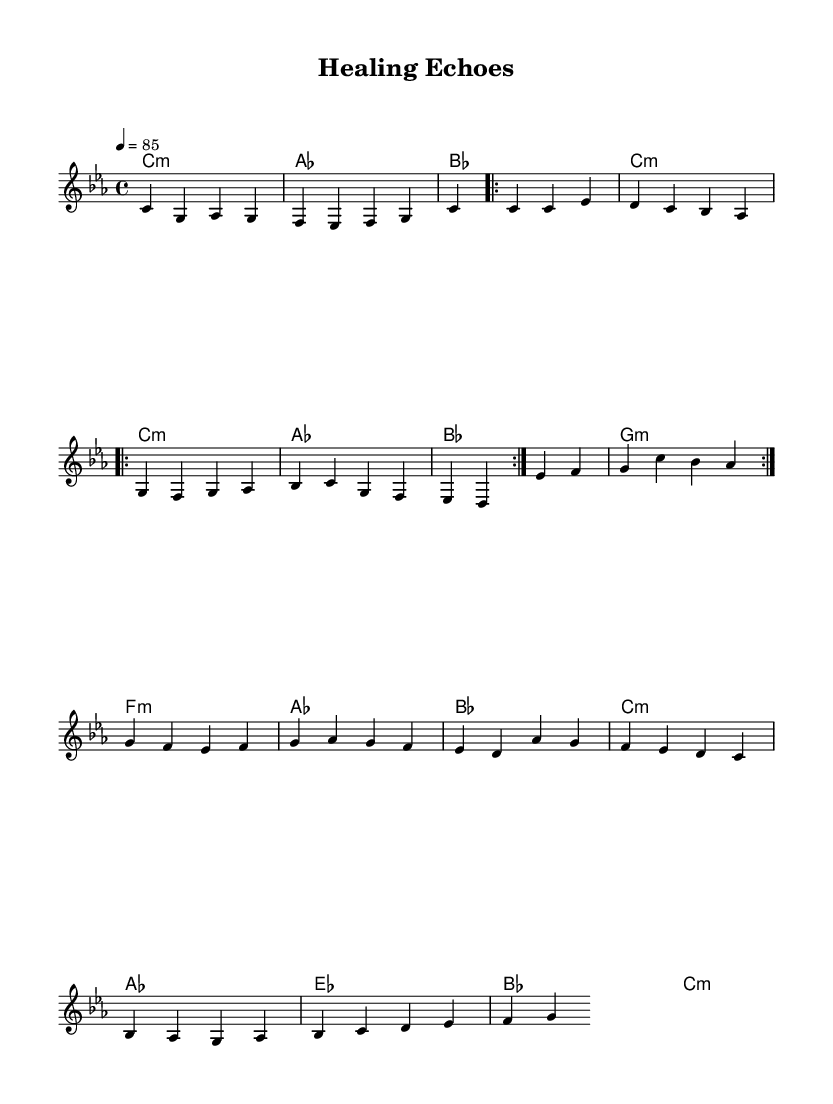What is the key signature of this music? The key signature is C minor, which consists of three flats (B flat, E flat, and A flat). It can be identified from the key signature placed after the clef sign.
Answer: C minor What is the time signature of this music? The time signature is 4/4, as indicated at the beginning of the sheet music, allowing four beats per measure with a quarter note receiving one beat.
Answer: 4/4 What is the tempo marking of this music? The tempo marking is set at 85 beats per minute, indicated by the tempo directive at the beginning, which tells musicians how fast to play the piece.
Answer: 85 How many measures are in the verse section? The verse section contains 8 measures, which can be calculated by counting the individual measures in the repeated volta section. Each repeat is one set of 4 measures repeated twice.
Answer: 8 What is the primary emotional theme addressed in this piece? The emotional theme addresses trauma and recovery, evident through the title "Healing Echoes" and the overall lyrical context intended for conscious rap, focusing on psychological struggles.
Answer: Trauma and recovery What is the structure of the music in terms of sections? The music has a structured form with four distinct sections: Intro, Verse, Chorus, and Bridge, indicating a typical arrangement often found in hip hop songs which highlight different lyrical themes and musical ideas.
Answer: Intro, Verse, Chorus, Bridge What mood does the harmony section convey throughout the music? The harmony section conveys a somber and reflective mood, as it employs minor chords predominantly, which enhances the emotional weight and aligns with the themes of healing and introspection prevalent in conscious rap.
Answer: Somber and reflective 